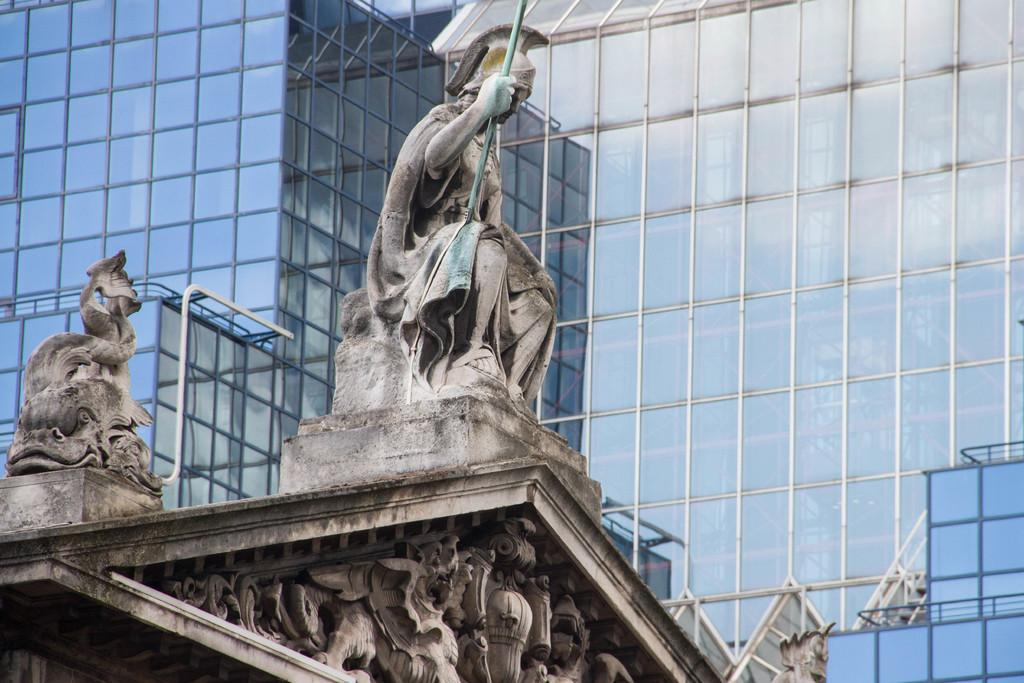What is the main subject in the center of the image? There is a building, a wall, and statues in the center of the image. Can you describe the building in the center of the image? The building in the center of the image has a wall and statues. What can be seen in the background of the image? There is a glass building in the background of the image. How does the maid in the image provide a haircut to the statues? There is no maid or haircut depicted in the image; it features a building, wall, statues, and a glass building in the background. 